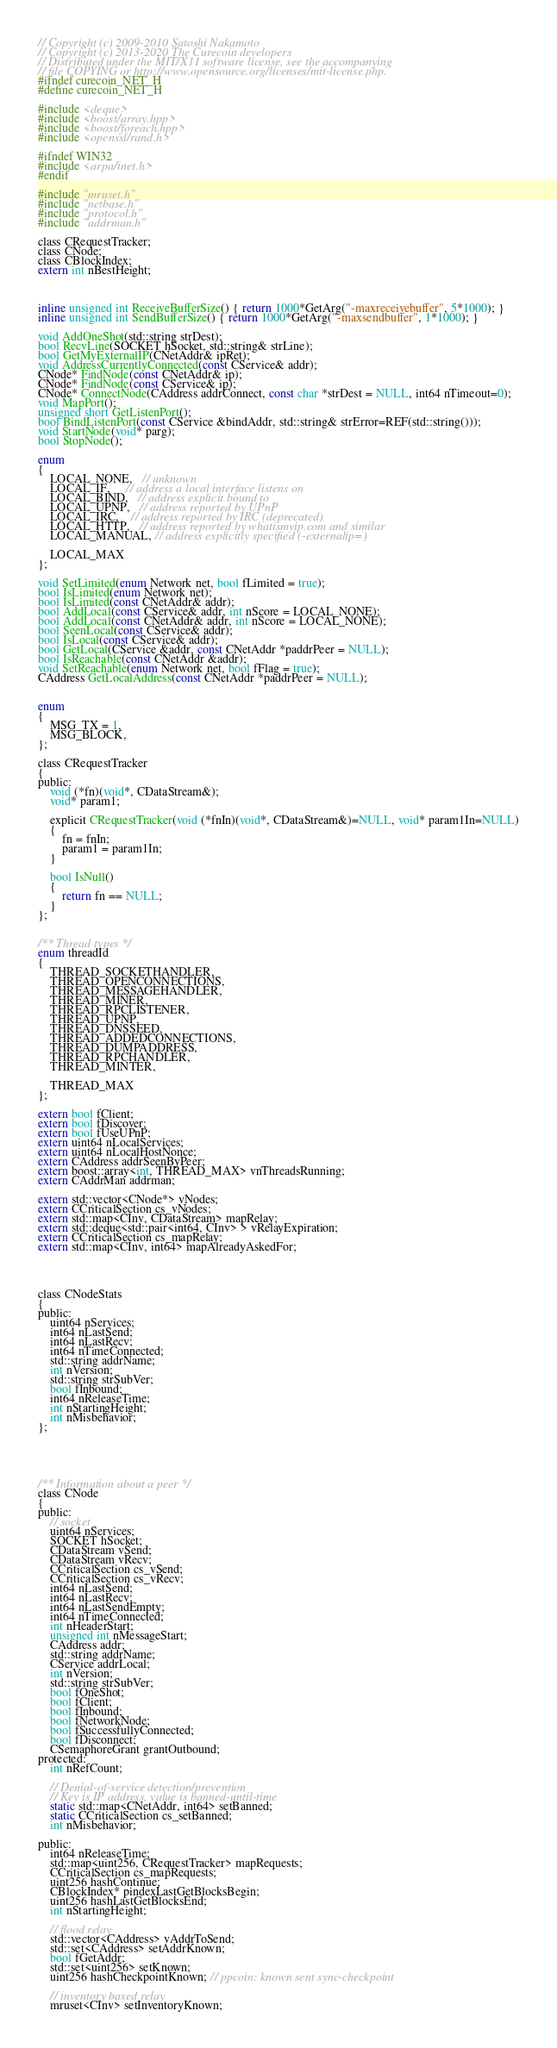Convert code to text. <code><loc_0><loc_0><loc_500><loc_500><_C_>// Copyright (c) 2009-2010 Satoshi Nakamoto
// Copyright (c) 2013-2020 The Curecoin developers
// Distributed under the MIT/X11 software license, see the accompanying
// file COPYING or http://www.opensource.org/licenses/mit-license.php.
#ifndef curecoin_NET_H
#define curecoin_NET_H

#include <deque>
#include <boost/array.hpp>
#include <boost/foreach.hpp>
#include <openssl/rand.h>

#ifndef WIN32
#include <arpa/inet.h>
#endif

#include "mruset.h"
#include "netbase.h"
#include "protocol.h"
#include "addrman.h"

class CRequestTracker;
class CNode;
class CBlockIndex;
extern int nBestHeight;



inline unsigned int ReceiveBufferSize() { return 1000*GetArg("-maxreceivebuffer", 5*1000); }
inline unsigned int SendBufferSize() { return 1000*GetArg("-maxsendbuffer", 1*1000); }

void AddOneShot(std::string strDest);
bool RecvLine(SOCKET hSocket, std::string& strLine);
bool GetMyExternalIP(CNetAddr& ipRet);
void AddressCurrentlyConnected(const CService& addr);
CNode* FindNode(const CNetAddr& ip);
CNode* FindNode(const CService& ip);
CNode* ConnectNode(CAddress addrConnect, const char *strDest = NULL, int64 nTimeout=0);
void MapPort();
unsigned short GetListenPort();
bool BindListenPort(const CService &bindAddr, std::string& strError=REF(std::string()));
void StartNode(void* parg);
bool StopNode();

enum
{
    LOCAL_NONE,   // unknown
    LOCAL_IF,     // address a local interface listens on
    LOCAL_BIND,   // address explicit bound to
    LOCAL_UPNP,   // address reported by UPnP
    LOCAL_IRC,    // address reported by IRC (deprecated)
    LOCAL_HTTP,   // address reported by whatismyip.com and similar
    LOCAL_MANUAL, // address explicitly specified (-externalip=)

    LOCAL_MAX
};

void SetLimited(enum Network net, bool fLimited = true);
bool IsLimited(enum Network net);
bool IsLimited(const CNetAddr& addr);
bool AddLocal(const CService& addr, int nScore = LOCAL_NONE);
bool AddLocal(const CNetAddr& addr, int nScore = LOCAL_NONE);
bool SeenLocal(const CService& addr);
bool IsLocal(const CService& addr);
bool GetLocal(CService &addr, const CNetAddr *paddrPeer = NULL);
bool IsReachable(const CNetAddr &addr);
void SetReachable(enum Network net, bool fFlag = true);
CAddress GetLocalAddress(const CNetAddr *paddrPeer = NULL);


enum
{
    MSG_TX = 1,
    MSG_BLOCK,
};

class CRequestTracker
{
public:
    void (*fn)(void*, CDataStream&);
    void* param1;

    explicit CRequestTracker(void (*fnIn)(void*, CDataStream&)=NULL, void* param1In=NULL)
    {
        fn = fnIn;
        param1 = param1In;
    }

    bool IsNull()
    {
        return fn == NULL;
    }
};


/** Thread types */
enum threadId
{
    THREAD_SOCKETHANDLER,
    THREAD_OPENCONNECTIONS,
    THREAD_MESSAGEHANDLER,
    THREAD_MINER,
    THREAD_RPCLISTENER,
    THREAD_UPNP,
    THREAD_DNSSEED,
    THREAD_ADDEDCONNECTIONS,
    THREAD_DUMPADDRESS,
    THREAD_RPCHANDLER,
    THREAD_MINTER,

    THREAD_MAX
};

extern bool fClient;
extern bool fDiscover;
extern bool fUseUPnP;
extern uint64 nLocalServices;
extern uint64 nLocalHostNonce;
extern CAddress addrSeenByPeer;
extern boost::array<int, THREAD_MAX> vnThreadsRunning;
extern CAddrMan addrman;

extern std::vector<CNode*> vNodes;
extern CCriticalSection cs_vNodes;
extern std::map<CInv, CDataStream> mapRelay;
extern std::deque<std::pair<int64, CInv> > vRelayExpiration;
extern CCriticalSection cs_mapRelay;
extern std::map<CInv, int64> mapAlreadyAskedFor;




class CNodeStats
{
public:
    uint64 nServices;
    int64 nLastSend;
    int64 nLastRecv;
    int64 nTimeConnected;
    std::string addrName;
    int nVersion;
    std::string strSubVer;
    bool fInbound;
    int64 nReleaseTime;
    int nStartingHeight;
    int nMisbehavior;
};





/** Information about a peer */
class CNode
{
public:
    // socket
    uint64 nServices;
    SOCKET hSocket;
    CDataStream vSend;
    CDataStream vRecv;
    CCriticalSection cs_vSend;
    CCriticalSection cs_vRecv;
    int64 nLastSend;
    int64 nLastRecv;
    int64 nLastSendEmpty;
    int64 nTimeConnected;
    int nHeaderStart;
    unsigned int nMessageStart;
    CAddress addr;
    std::string addrName;
    CService addrLocal;
    int nVersion;
    std::string strSubVer;
    bool fOneShot;
    bool fClient;
    bool fInbound;
    bool fNetworkNode;
    bool fSuccessfullyConnected;
    bool fDisconnect;
    CSemaphoreGrant grantOutbound;
protected:
    int nRefCount;

    // Denial-of-service detection/prevention
    // Key is IP address, value is banned-until-time
    static std::map<CNetAddr, int64> setBanned;
    static CCriticalSection cs_setBanned;
    int nMisbehavior;

public:
    int64 nReleaseTime;
    std::map<uint256, CRequestTracker> mapRequests;
    CCriticalSection cs_mapRequests;
    uint256 hashContinue;
    CBlockIndex* pindexLastGetBlocksBegin;
    uint256 hashLastGetBlocksEnd;
    int nStartingHeight;

    // flood relay
    std::vector<CAddress> vAddrToSend;
    std::set<CAddress> setAddrKnown;
    bool fGetAddr;
    std::set<uint256> setKnown;
    uint256 hashCheckpointKnown; // ppcoin: known sent sync-checkpoint

    // inventory based relay
    mruset<CInv> setInventoryKnown;</code> 